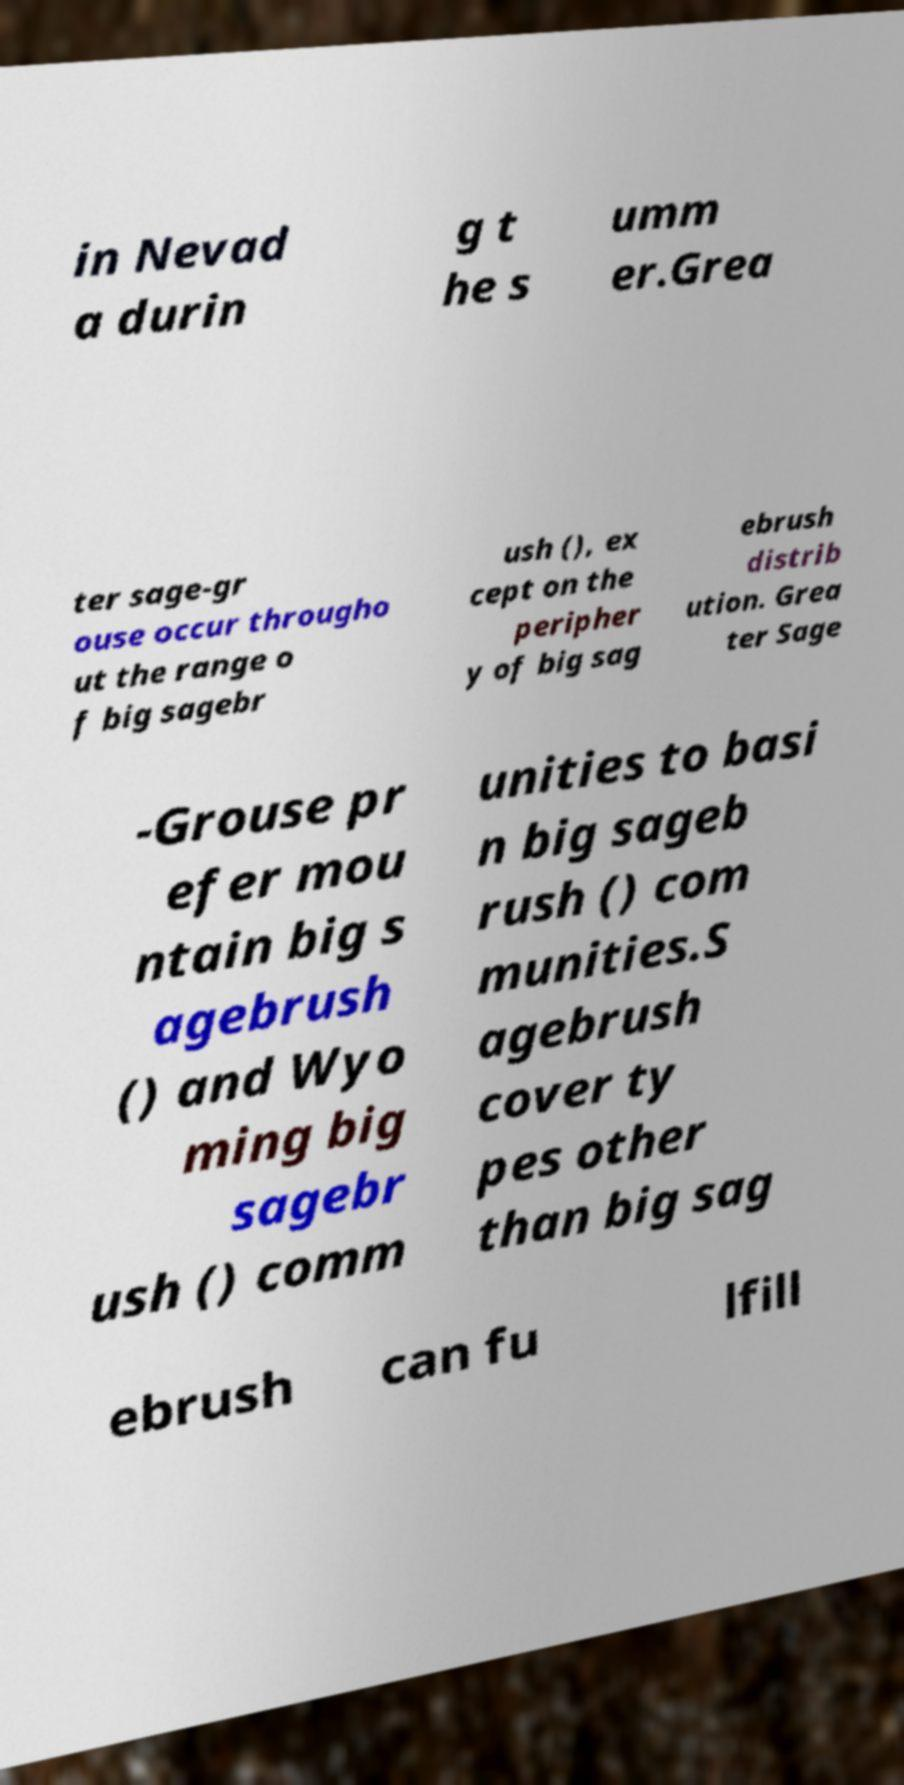Could you assist in decoding the text presented in this image and type it out clearly? in Nevad a durin g t he s umm er.Grea ter sage-gr ouse occur througho ut the range o f big sagebr ush (), ex cept on the peripher y of big sag ebrush distrib ution. Grea ter Sage -Grouse pr efer mou ntain big s agebrush () and Wyo ming big sagebr ush () comm unities to basi n big sageb rush () com munities.S agebrush cover ty pes other than big sag ebrush can fu lfill 